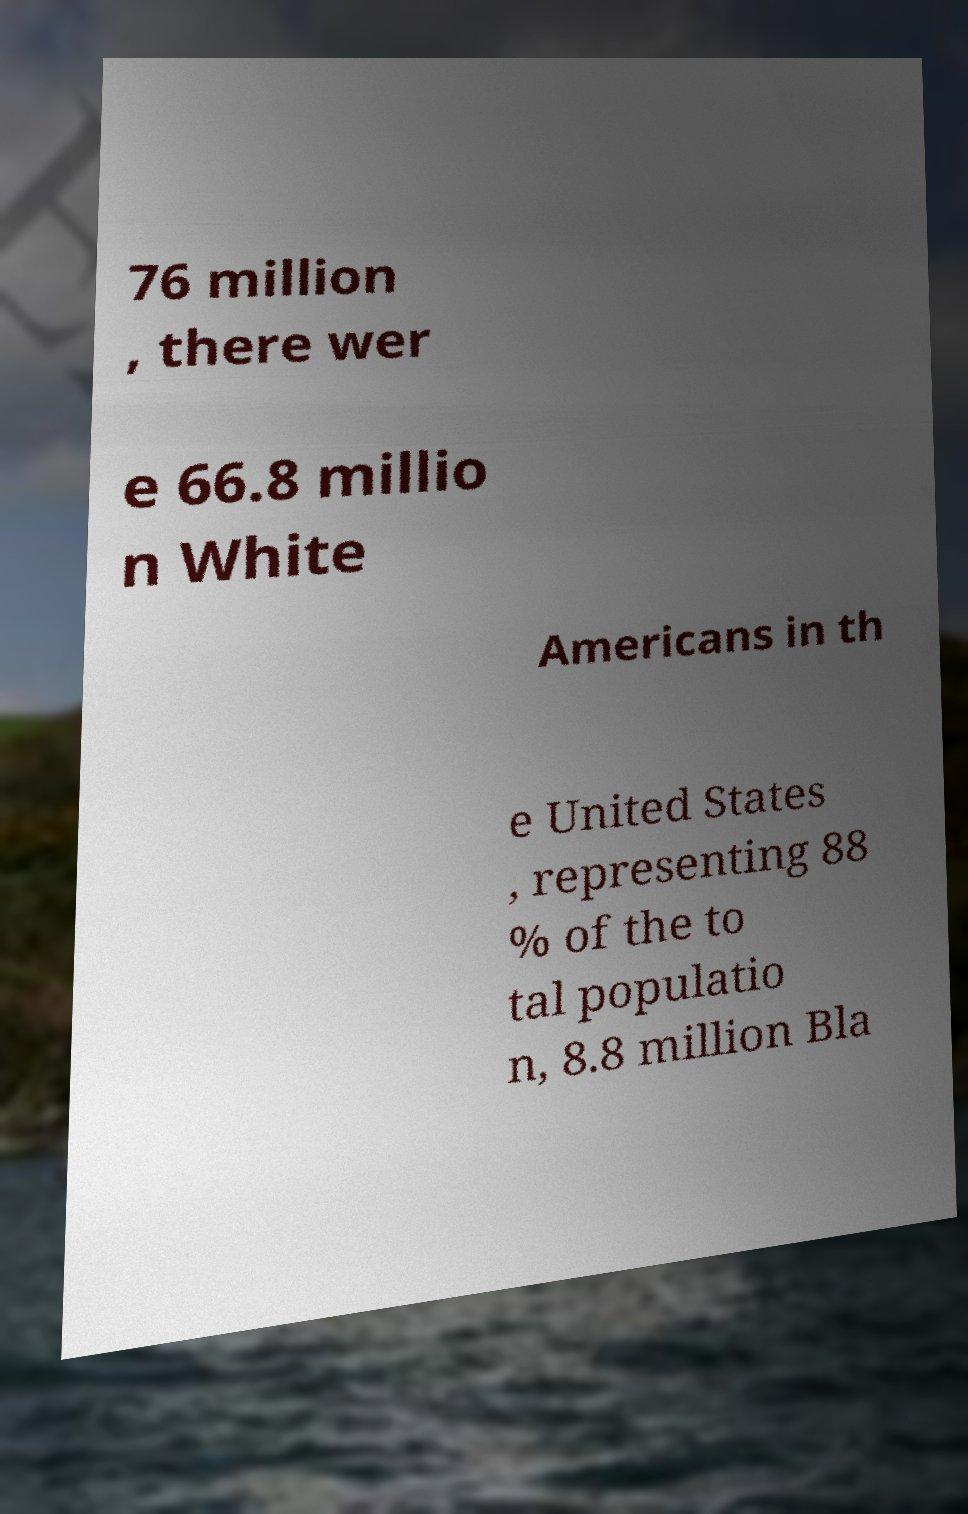Please identify and transcribe the text found in this image. 76 million , there wer e 66.8 millio n White Americans in th e United States , representing 88 % of the to tal populatio n, 8.8 million Bla 